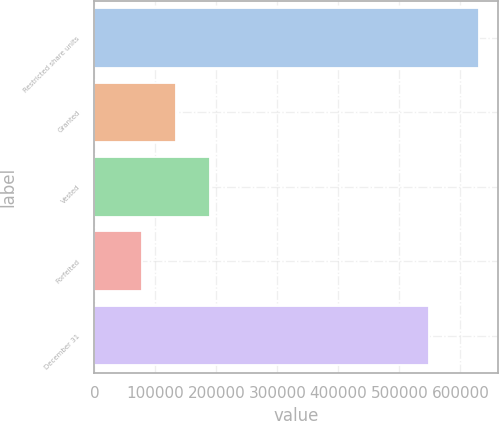Convert chart to OTSL. <chart><loc_0><loc_0><loc_500><loc_500><bar_chart><fcel>Restricted share units<fcel>Granted<fcel>Vested<fcel>Forfeited<fcel>December 31<nl><fcel>630212<fcel>133838<fcel>188990<fcel>78685<fcel>548354<nl></chart> 